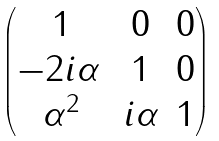<formula> <loc_0><loc_0><loc_500><loc_500>\begin{pmatrix} 1 & 0 & 0 \\ - 2 i \alpha \, & 1 & 0 \\ \alpha ^ { 2 } & i \alpha & 1 \end{pmatrix}</formula> 